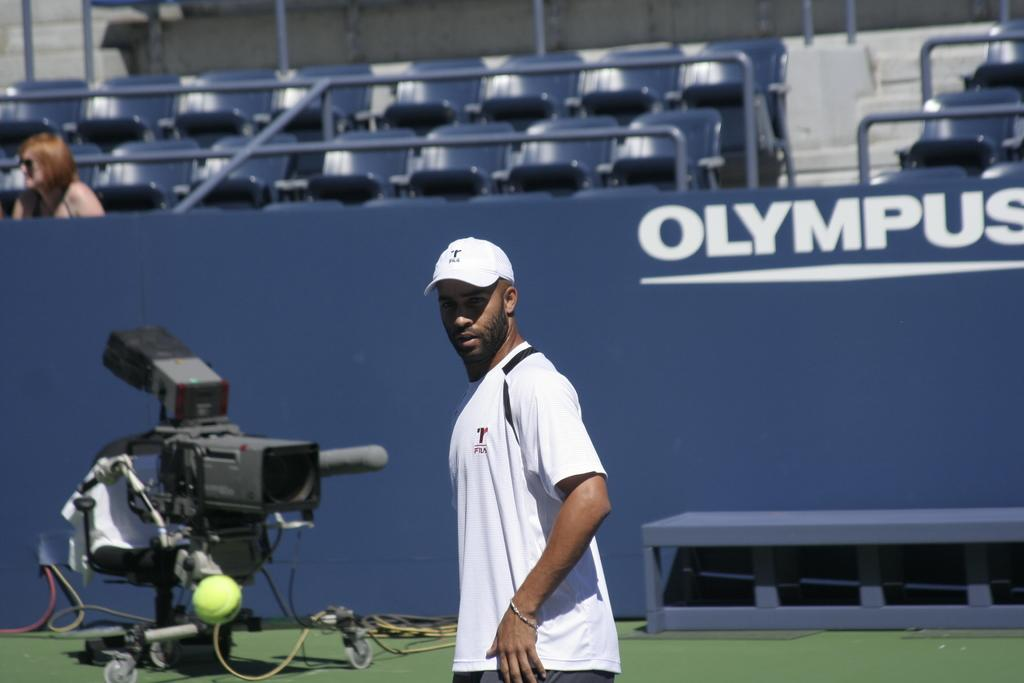<image>
Summarize the visual content of the image. A tennis player passes by an Olympus advertisement on the court's wall. 